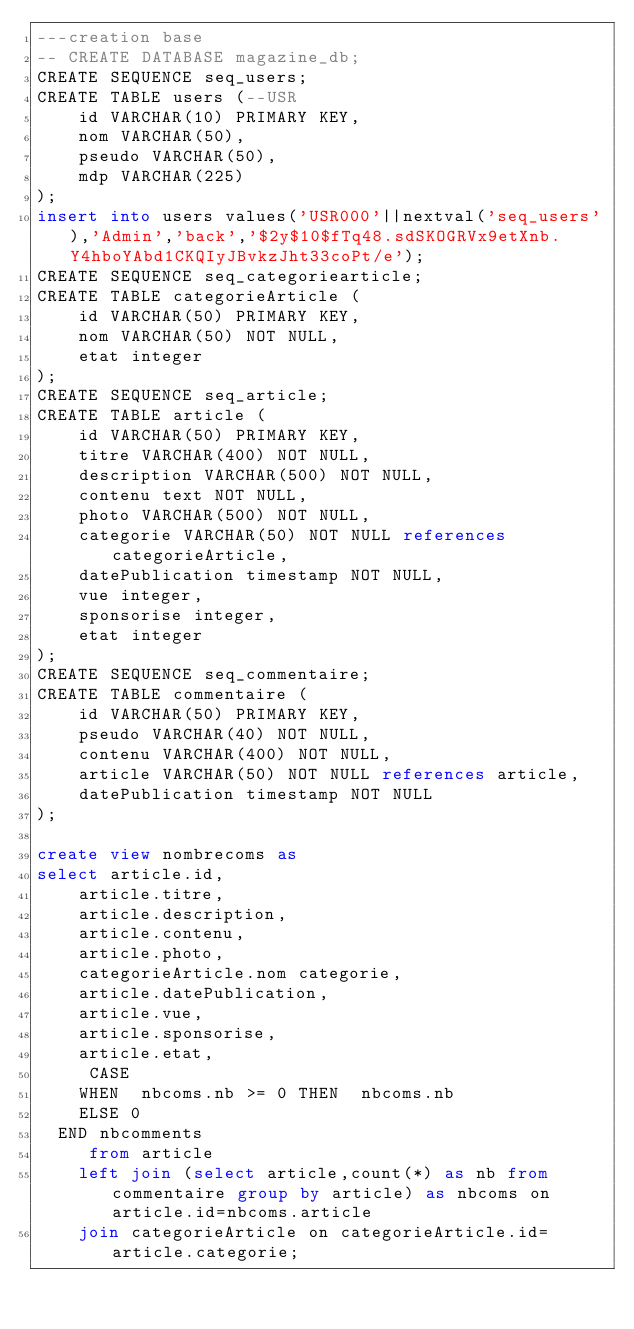<code> <loc_0><loc_0><loc_500><loc_500><_SQL_>---creation base
-- CREATE DATABASE magazine_db;
CREATE SEQUENCE seq_users;
CREATE TABLE users (--USR
    id VARCHAR(10) PRIMARY KEY,
    nom VARCHAR(50),
    pseudo VARCHAR(50),
    mdp VARCHAR(225)
);
insert into users values('USR000'||nextval('seq_users'),'Admin','back','$2y$10$fTq48.sdSKOGRVx9etXnb.Y4hboYAbd1CKQIyJBvkzJht33coPt/e');
CREATE SEQUENCE seq_categoriearticle;
CREATE TABLE categorieArticle (
    id VARCHAR(50) PRIMARY KEY,
    nom VARCHAR(50) NOT NULL,
    etat integer
);
CREATE SEQUENCE seq_article;
CREATE TABLE article (
    id VARCHAR(50) PRIMARY KEY,
    titre VARCHAR(400) NOT NULL,
    description VARCHAR(500) NOT NULL,
    contenu text NOT NULL,
    photo VARCHAR(500) NOT NULL,
    categorie VARCHAR(50) NOT NULL references categorieArticle,
    datePublication timestamp NOT NULL,
    vue integer,
    sponsorise integer,
    etat integer
);
CREATE SEQUENCE seq_commentaire;
CREATE TABLE commentaire (
    id VARCHAR(50) PRIMARY KEY,
    pseudo VARCHAR(40) NOT NULL,
    contenu VARCHAR(400) NOT NULL,
    article VARCHAR(50) NOT NULL references article,
    datePublication timestamp NOT NULL
);

create view nombrecoms as
select article.id,
    article.titre,
    article.description,
    article.contenu,
    article.photo,
    categorieArticle.nom categorie,
    article.datePublication,
    article.vue,
    article.sponsorise,
    article.etat,
     CASE
    WHEN  nbcoms.nb >= 0 THEN  nbcoms.nb
    ELSE 0
  END nbcomments
     from article 
    left join (select article,count(*) as nb from commentaire group by article) as nbcoms on article.id=nbcoms.article
    join categorieArticle on categorieArticle.id=article.categorie;
</code> 